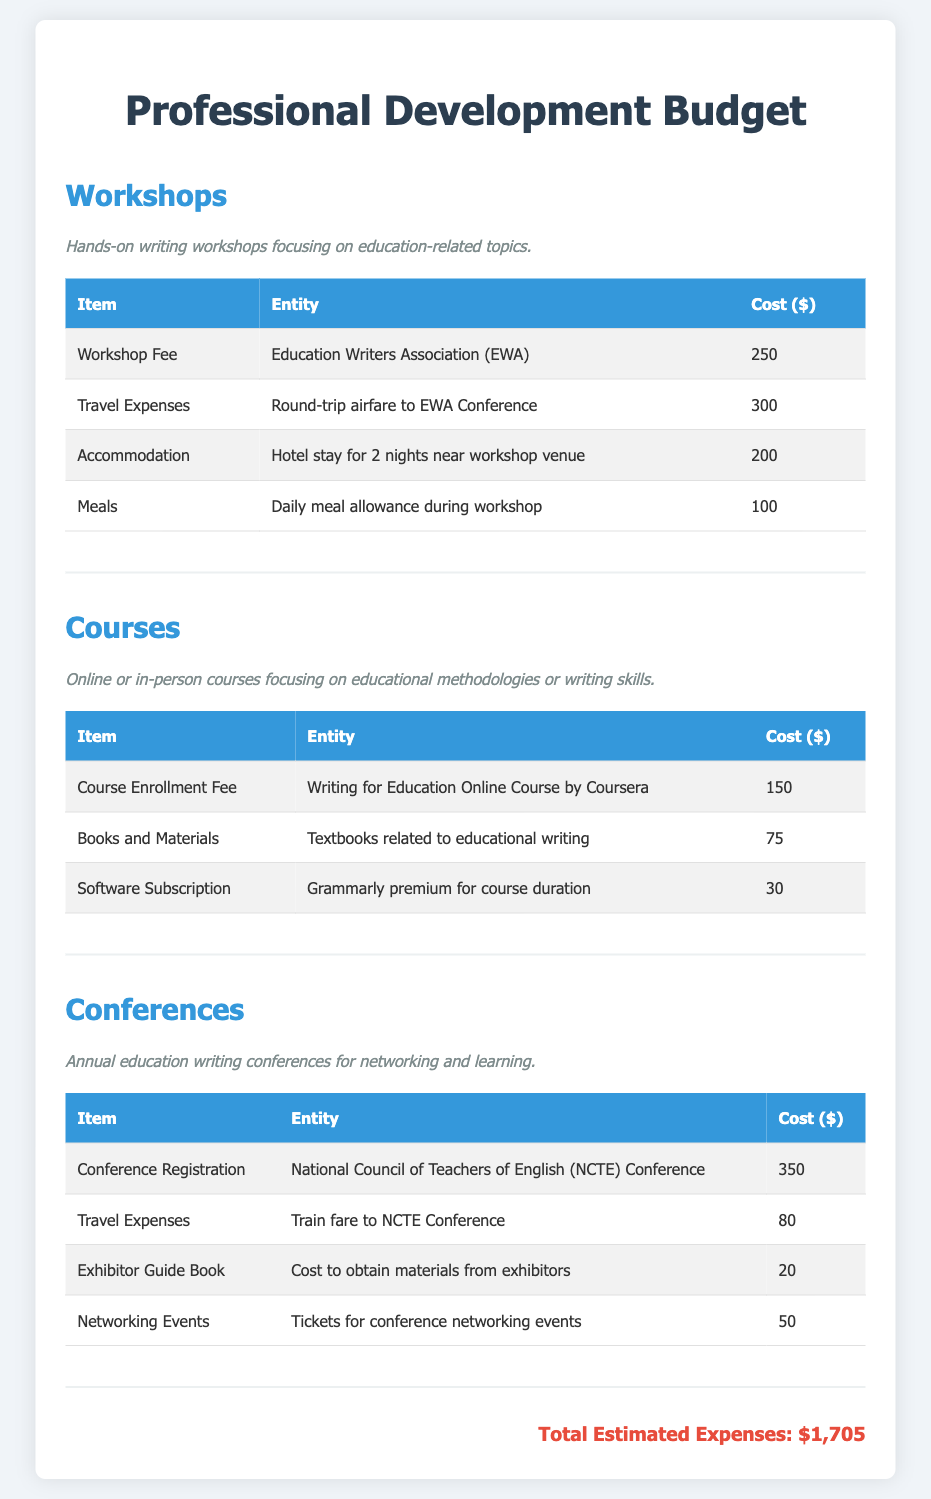What is the total estimated expenses? The total estimated expenses is listed at the bottom of the document, summing up all the costs provided in the sections.
Answer: $1,705 What is the cost of the Workshop Fee? The Workshop Fee is the cost related to attending the workshop and is provided in the Workshops section of the document.
Answer: $250 How much is the Course Enrollment Fee for the Writing for Education Online Course? The Course Enrollment Fee is specifically mentioned in the Courses section and provides information about the training cost.
Answer: $150 What is the cost of travel expenses to the NCTE Conference? This cost is included in the Conferences section under Travel Expenses for the NCTE Conference.
Answer: $80 What agency holds the workshop mentioned in the document? The agency that organizes the workshop is specified in the Workshops section of the budget.
Answer: Education Writers Association (EWA) How many nights does the accommodation cover for the workshop? The duration of the accommodation in nights is indicated in the Workshops section, describing the hotel stay.
Answer: 2 nights What additional expenses are listed for the Courses section? The additional expenses are provided in a detailed table in the Courses section under the relevant items related to course costs.
Answer: Books and Materials, Software Subscription What type of events are included in the Conferences section? The document describes a few types of events within the Conferences section, emphasizing networking opportunities.
Answer: Networking Events What is the cost of the Exhibitor Guide Book? The cost for obtaining materials from exhibitors at the conference is explicitly mentioned in the Conferences section.
Answer: $20 